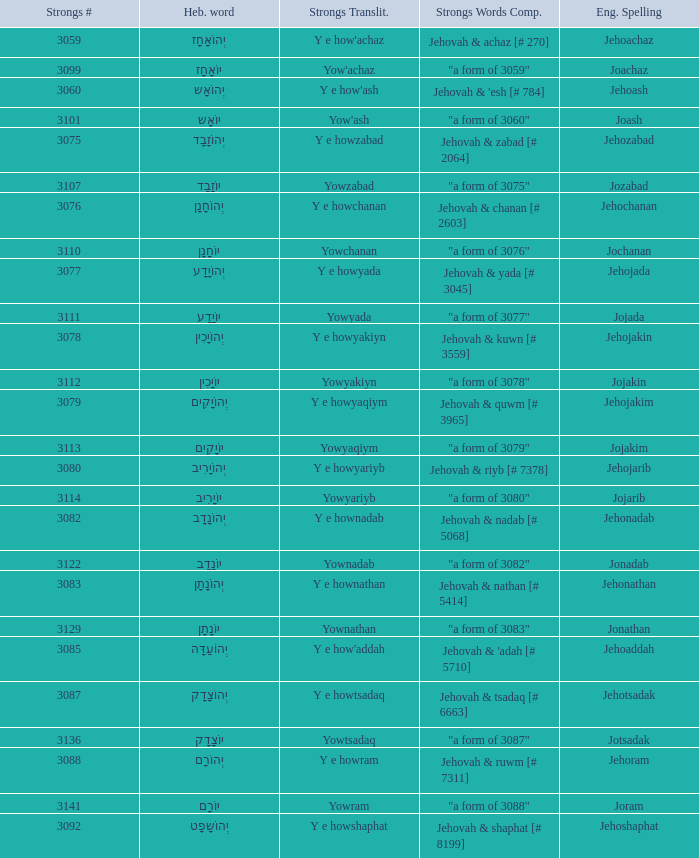What is the strongs transliteration of the hebrew word יוֹחָנָן? Yowchanan. 